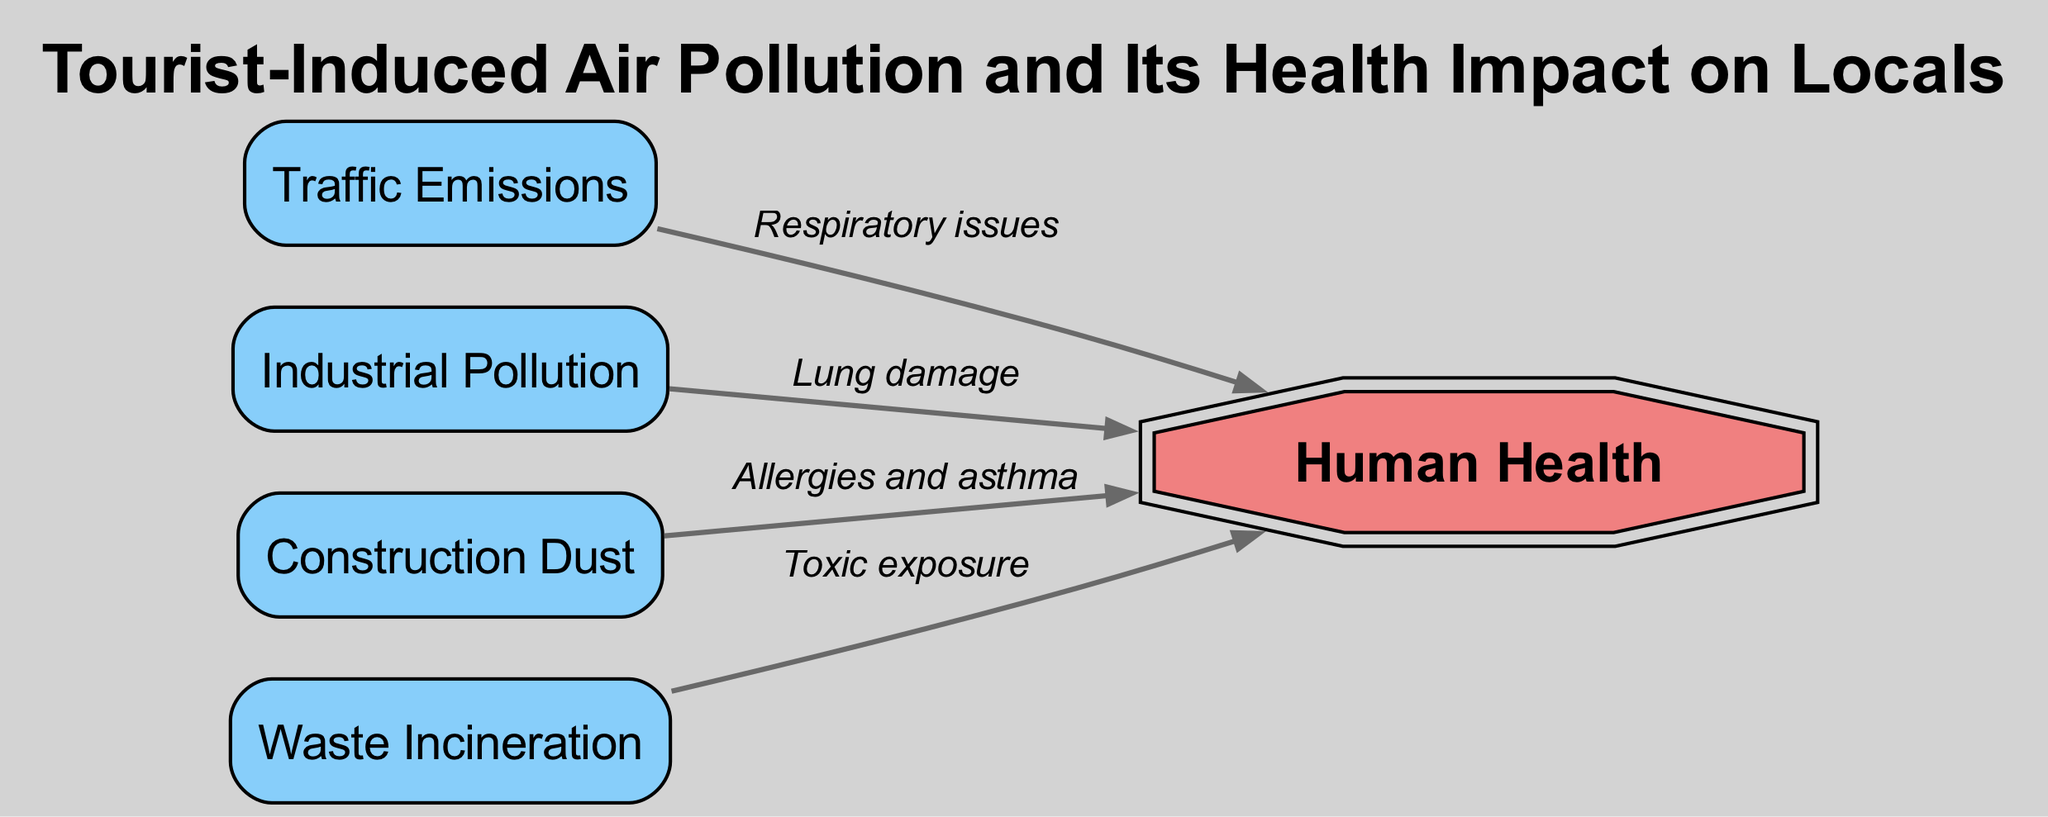What are the sources of air pollution depicted in the diagram? The nodes labeled "Traffic Emissions," "Industrial Pollution," "Construction Dust," and "Waste Incineration" represent the primary sources of air pollution shown in the diagram.
Answer: Traffic Emissions, Industrial Pollution, Construction Dust, Waste Incineration How many edges connect pollution sources to human health? The diagram shows four edges, each linking one of the pollution sources to the "Human Health" node, indicating the impact of air pollution on health.
Answer: 4 What health issue is associated with construction dust? The edge connecting "Construction Dust" to "Human Health" specifies that the associated health issues are "Allergies and asthma."
Answer: Allergies and asthma Which pollution source has the relationship labeled "Toxic exposure"? The edge labeled "Toxic exposure" connects from "Waste Incineration" to "Human Health," indicating the health impact associated with that source.
Answer: Waste Incineration Which pollution source contributes to respiratory issues? The label on the edge from "Traffic Emissions" to "Human Health" states "Respiratory issues," indicating this specific source's impact.
Answer: Traffic Emissions What type of node is "Human Health"? The "Human Health" node is depicted as a double octagon, which is a distinctive representation within the diagram, signifying its importance and impact.
Answer: Double octagon Which pollution source is explicitly linked to lung damage? The edge labeled "Lung damage" connects "Industrial Pollution" to "Human Health," making it clear that this source has that specific health impact.
Answer: Industrial Pollution What impacts do traffic emissions have on local residents? The diagram clearly indicates "Respiratory issues" as the health effect associated with traffic emissions, showing the negative impact on air quality.
Answer: Respiratory issues How does waste incineration relate to human health according to the diagram? The diagram illustrates an edge connecting "Waste Incineration" to "Human Health," labeled "Toxic exposure," underscoring the health risks involved.
Answer: Toxic exposure 